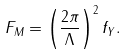<formula> <loc_0><loc_0><loc_500><loc_500>F _ { M } = \left ( \frac { 2 \pi } { \Lambda } \right ) ^ { 2 } f _ { Y } .</formula> 